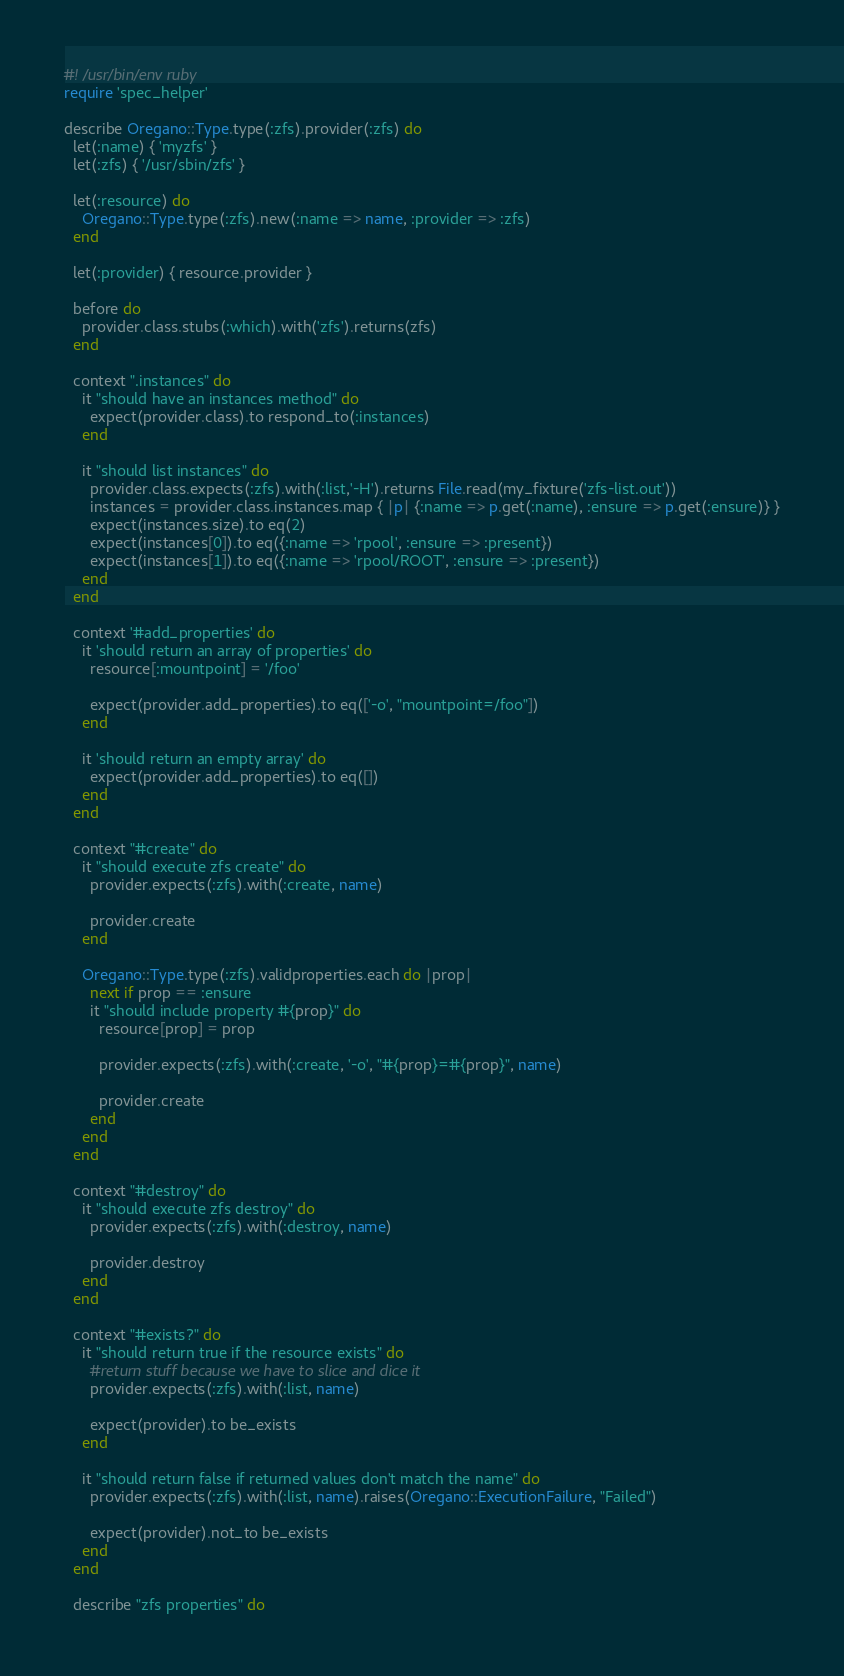<code> <loc_0><loc_0><loc_500><loc_500><_Ruby_>#! /usr/bin/env ruby
require 'spec_helper'

describe Oregano::Type.type(:zfs).provider(:zfs) do
  let(:name) { 'myzfs' }
  let(:zfs) { '/usr/sbin/zfs' }

  let(:resource) do
    Oregano::Type.type(:zfs).new(:name => name, :provider => :zfs)
  end

  let(:provider) { resource.provider }

  before do
    provider.class.stubs(:which).with('zfs').returns(zfs)
  end

  context ".instances" do
    it "should have an instances method" do
      expect(provider.class).to respond_to(:instances)
    end

    it "should list instances" do
      provider.class.expects(:zfs).with(:list,'-H').returns File.read(my_fixture('zfs-list.out'))
      instances = provider.class.instances.map { |p| {:name => p.get(:name), :ensure => p.get(:ensure)} }
      expect(instances.size).to eq(2)
      expect(instances[0]).to eq({:name => 'rpool', :ensure => :present})
      expect(instances[1]).to eq({:name => 'rpool/ROOT', :ensure => :present})
    end
  end

  context '#add_properties' do
    it 'should return an array of properties' do
      resource[:mountpoint] = '/foo'

      expect(provider.add_properties).to eq(['-o', "mountpoint=/foo"])
    end

    it 'should return an empty array' do
      expect(provider.add_properties).to eq([])
    end
  end

  context "#create" do
    it "should execute zfs create" do
      provider.expects(:zfs).with(:create, name)

      provider.create
    end

    Oregano::Type.type(:zfs).validproperties.each do |prop|
      next if prop == :ensure
      it "should include property #{prop}" do
        resource[prop] = prop

        provider.expects(:zfs).with(:create, '-o', "#{prop}=#{prop}", name)

        provider.create
      end
    end
  end

  context "#destroy" do
    it "should execute zfs destroy" do
      provider.expects(:zfs).with(:destroy, name)

      provider.destroy
    end
  end

  context "#exists?" do
    it "should return true if the resource exists" do
      #return stuff because we have to slice and dice it
      provider.expects(:zfs).with(:list, name)

      expect(provider).to be_exists
    end

    it "should return false if returned values don't match the name" do
      provider.expects(:zfs).with(:list, name).raises(Oregano::ExecutionFailure, "Failed")

      expect(provider).not_to be_exists
    end
  end

  describe "zfs properties" do</code> 